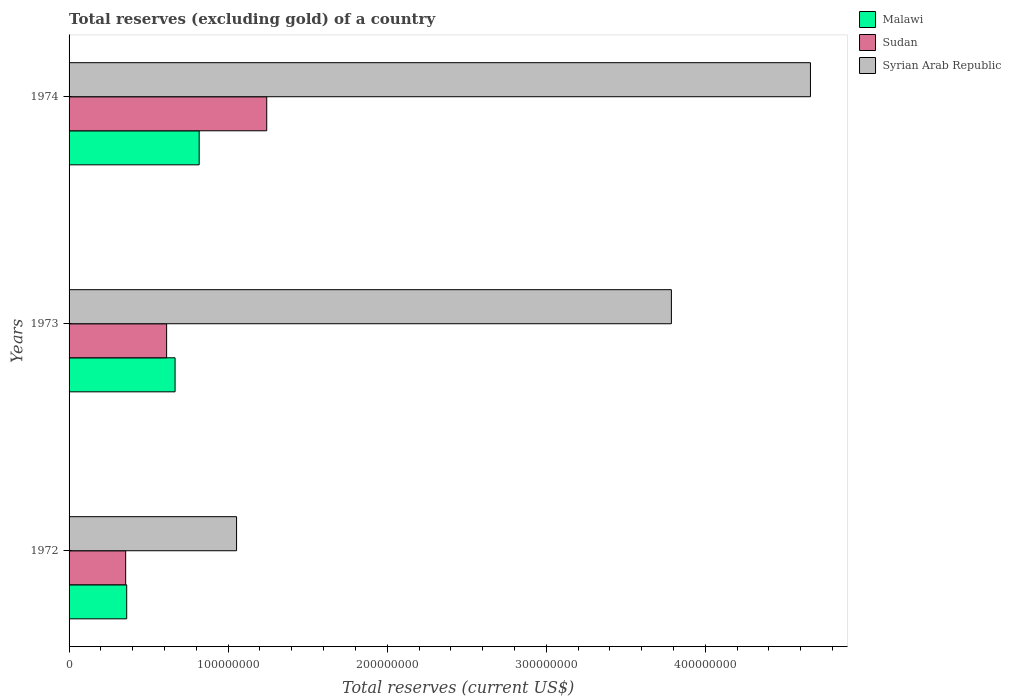How many groups of bars are there?
Your answer should be very brief. 3. Are the number of bars per tick equal to the number of legend labels?
Your response must be concise. Yes. Are the number of bars on each tick of the Y-axis equal?
Offer a terse response. Yes. How many bars are there on the 2nd tick from the top?
Your answer should be very brief. 3. What is the total reserves (excluding gold) in Malawi in 1972?
Your answer should be very brief. 3.62e+07. Across all years, what is the maximum total reserves (excluding gold) in Malawi?
Give a very brief answer. 8.18e+07. Across all years, what is the minimum total reserves (excluding gold) in Syrian Arab Republic?
Give a very brief answer. 1.05e+08. In which year was the total reserves (excluding gold) in Sudan maximum?
Make the answer very short. 1974. In which year was the total reserves (excluding gold) in Syrian Arab Republic minimum?
Give a very brief answer. 1972. What is the total total reserves (excluding gold) in Sudan in the graph?
Offer a terse response. 2.21e+08. What is the difference between the total reserves (excluding gold) in Malawi in 1972 and that in 1974?
Provide a short and direct response. -4.56e+07. What is the difference between the total reserves (excluding gold) in Syrian Arab Republic in 1973 and the total reserves (excluding gold) in Sudan in 1974?
Provide a short and direct response. 2.54e+08. What is the average total reserves (excluding gold) in Sudan per year?
Make the answer very short. 7.37e+07. In the year 1972, what is the difference between the total reserves (excluding gold) in Sudan and total reserves (excluding gold) in Malawi?
Provide a short and direct response. -6.50e+05. In how many years, is the total reserves (excluding gold) in Sudan greater than 160000000 US$?
Offer a terse response. 0. What is the ratio of the total reserves (excluding gold) in Syrian Arab Republic in 1972 to that in 1974?
Your response must be concise. 0.23. Is the total reserves (excluding gold) in Sudan in 1972 less than that in 1973?
Your response must be concise. Yes. Is the difference between the total reserves (excluding gold) in Sudan in 1972 and 1973 greater than the difference between the total reserves (excluding gold) in Malawi in 1972 and 1973?
Provide a short and direct response. Yes. What is the difference between the highest and the second highest total reserves (excluding gold) in Sudan?
Ensure brevity in your answer.  6.29e+07. What is the difference between the highest and the lowest total reserves (excluding gold) in Sudan?
Your response must be concise. 8.87e+07. Is the sum of the total reserves (excluding gold) in Syrian Arab Republic in 1972 and 1974 greater than the maximum total reserves (excluding gold) in Malawi across all years?
Offer a terse response. Yes. What does the 1st bar from the top in 1973 represents?
Offer a very short reply. Syrian Arab Republic. What does the 3rd bar from the bottom in 1972 represents?
Make the answer very short. Syrian Arab Republic. How many bars are there?
Keep it short and to the point. 9. Does the graph contain any zero values?
Offer a very short reply. No. Does the graph contain grids?
Give a very brief answer. No. Where does the legend appear in the graph?
Keep it short and to the point. Top right. What is the title of the graph?
Make the answer very short. Total reserves (excluding gold) of a country. Does "Bosnia and Herzegovina" appear as one of the legend labels in the graph?
Your response must be concise. No. What is the label or title of the X-axis?
Your response must be concise. Total reserves (current US$). What is the Total reserves (current US$) in Malawi in 1972?
Provide a short and direct response. 3.62e+07. What is the Total reserves (current US$) in Sudan in 1972?
Provide a succinct answer. 3.56e+07. What is the Total reserves (current US$) of Syrian Arab Republic in 1972?
Your response must be concise. 1.05e+08. What is the Total reserves (current US$) in Malawi in 1973?
Provide a short and direct response. 6.66e+07. What is the Total reserves (current US$) of Sudan in 1973?
Offer a very short reply. 6.13e+07. What is the Total reserves (current US$) of Syrian Arab Republic in 1973?
Your answer should be very brief. 3.79e+08. What is the Total reserves (current US$) of Malawi in 1974?
Provide a short and direct response. 8.18e+07. What is the Total reserves (current US$) in Sudan in 1974?
Keep it short and to the point. 1.24e+08. What is the Total reserves (current US$) of Syrian Arab Republic in 1974?
Make the answer very short. 4.66e+08. Across all years, what is the maximum Total reserves (current US$) of Malawi?
Ensure brevity in your answer.  8.18e+07. Across all years, what is the maximum Total reserves (current US$) in Sudan?
Provide a short and direct response. 1.24e+08. Across all years, what is the maximum Total reserves (current US$) of Syrian Arab Republic?
Provide a succinct answer. 4.66e+08. Across all years, what is the minimum Total reserves (current US$) of Malawi?
Give a very brief answer. 3.62e+07. Across all years, what is the minimum Total reserves (current US$) of Sudan?
Your response must be concise. 3.56e+07. Across all years, what is the minimum Total reserves (current US$) in Syrian Arab Republic?
Your answer should be very brief. 1.05e+08. What is the total Total reserves (current US$) of Malawi in the graph?
Your answer should be compact. 1.85e+08. What is the total Total reserves (current US$) of Sudan in the graph?
Your response must be concise. 2.21e+08. What is the total Total reserves (current US$) in Syrian Arab Republic in the graph?
Give a very brief answer. 9.50e+08. What is the difference between the Total reserves (current US$) in Malawi in 1972 and that in 1973?
Provide a succinct answer. -3.04e+07. What is the difference between the Total reserves (current US$) of Sudan in 1972 and that in 1973?
Your response must be concise. -2.57e+07. What is the difference between the Total reserves (current US$) in Syrian Arab Republic in 1972 and that in 1973?
Your answer should be compact. -2.73e+08. What is the difference between the Total reserves (current US$) in Malawi in 1972 and that in 1974?
Offer a very short reply. -4.56e+07. What is the difference between the Total reserves (current US$) in Sudan in 1972 and that in 1974?
Keep it short and to the point. -8.87e+07. What is the difference between the Total reserves (current US$) in Syrian Arab Republic in 1972 and that in 1974?
Your response must be concise. -3.61e+08. What is the difference between the Total reserves (current US$) of Malawi in 1973 and that in 1974?
Your answer should be very brief. -1.51e+07. What is the difference between the Total reserves (current US$) in Sudan in 1973 and that in 1974?
Ensure brevity in your answer.  -6.29e+07. What is the difference between the Total reserves (current US$) in Syrian Arab Republic in 1973 and that in 1974?
Your answer should be compact. -8.74e+07. What is the difference between the Total reserves (current US$) in Malawi in 1972 and the Total reserves (current US$) in Sudan in 1973?
Provide a succinct answer. -2.51e+07. What is the difference between the Total reserves (current US$) in Malawi in 1972 and the Total reserves (current US$) in Syrian Arab Republic in 1973?
Keep it short and to the point. -3.42e+08. What is the difference between the Total reserves (current US$) in Sudan in 1972 and the Total reserves (current US$) in Syrian Arab Republic in 1973?
Provide a succinct answer. -3.43e+08. What is the difference between the Total reserves (current US$) of Malawi in 1972 and the Total reserves (current US$) of Sudan in 1974?
Provide a succinct answer. -8.80e+07. What is the difference between the Total reserves (current US$) of Malawi in 1972 and the Total reserves (current US$) of Syrian Arab Republic in 1974?
Provide a succinct answer. -4.30e+08. What is the difference between the Total reserves (current US$) in Sudan in 1972 and the Total reserves (current US$) in Syrian Arab Republic in 1974?
Ensure brevity in your answer.  -4.31e+08. What is the difference between the Total reserves (current US$) of Malawi in 1973 and the Total reserves (current US$) of Sudan in 1974?
Keep it short and to the point. -5.76e+07. What is the difference between the Total reserves (current US$) of Malawi in 1973 and the Total reserves (current US$) of Syrian Arab Republic in 1974?
Give a very brief answer. -3.99e+08. What is the difference between the Total reserves (current US$) in Sudan in 1973 and the Total reserves (current US$) in Syrian Arab Republic in 1974?
Give a very brief answer. -4.05e+08. What is the average Total reserves (current US$) in Malawi per year?
Your answer should be very brief. 6.16e+07. What is the average Total reserves (current US$) in Sudan per year?
Your response must be concise. 7.37e+07. What is the average Total reserves (current US$) in Syrian Arab Republic per year?
Offer a terse response. 3.17e+08. In the year 1972, what is the difference between the Total reserves (current US$) of Malawi and Total reserves (current US$) of Sudan?
Ensure brevity in your answer.  6.50e+05. In the year 1972, what is the difference between the Total reserves (current US$) of Malawi and Total reserves (current US$) of Syrian Arab Republic?
Your answer should be compact. -6.91e+07. In the year 1972, what is the difference between the Total reserves (current US$) of Sudan and Total reserves (current US$) of Syrian Arab Republic?
Offer a very short reply. -6.97e+07. In the year 1973, what is the difference between the Total reserves (current US$) of Malawi and Total reserves (current US$) of Sudan?
Give a very brief answer. 5.31e+06. In the year 1973, what is the difference between the Total reserves (current US$) of Malawi and Total reserves (current US$) of Syrian Arab Republic?
Keep it short and to the point. -3.12e+08. In the year 1973, what is the difference between the Total reserves (current US$) of Sudan and Total reserves (current US$) of Syrian Arab Republic?
Offer a terse response. -3.17e+08. In the year 1974, what is the difference between the Total reserves (current US$) of Malawi and Total reserves (current US$) of Sudan?
Offer a very short reply. -4.25e+07. In the year 1974, what is the difference between the Total reserves (current US$) of Malawi and Total reserves (current US$) of Syrian Arab Republic?
Your response must be concise. -3.84e+08. In the year 1974, what is the difference between the Total reserves (current US$) of Sudan and Total reserves (current US$) of Syrian Arab Republic?
Offer a very short reply. -3.42e+08. What is the ratio of the Total reserves (current US$) in Malawi in 1972 to that in 1973?
Offer a very short reply. 0.54. What is the ratio of the Total reserves (current US$) of Sudan in 1972 to that in 1973?
Provide a succinct answer. 0.58. What is the ratio of the Total reserves (current US$) in Syrian Arab Republic in 1972 to that in 1973?
Your answer should be very brief. 0.28. What is the ratio of the Total reserves (current US$) of Malawi in 1972 to that in 1974?
Your answer should be very brief. 0.44. What is the ratio of the Total reserves (current US$) in Sudan in 1972 to that in 1974?
Offer a terse response. 0.29. What is the ratio of the Total reserves (current US$) of Syrian Arab Republic in 1972 to that in 1974?
Make the answer very short. 0.23. What is the ratio of the Total reserves (current US$) of Malawi in 1973 to that in 1974?
Make the answer very short. 0.81. What is the ratio of the Total reserves (current US$) of Sudan in 1973 to that in 1974?
Offer a very short reply. 0.49. What is the ratio of the Total reserves (current US$) of Syrian Arab Republic in 1973 to that in 1974?
Ensure brevity in your answer.  0.81. What is the difference between the highest and the second highest Total reserves (current US$) of Malawi?
Give a very brief answer. 1.51e+07. What is the difference between the highest and the second highest Total reserves (current US$) of Sudan?
Offer a terse response. 6.29e+07. What is the difference between the highest and the second highest Total reserves (current US$) in Syrian Arab Republic?
Your answer should be very brief. 8.74e+07. What is the difference between the highest and the lowest Total reserves (current US$) of Malawi?
Your answer should be compact. 4.56e+07. What is the difference between the highest and the lowest Total reserves (current US$) of Sudan?
Offer a very short reply. 8.87e+07. What is the difference between the highest and the lowest Total reserves (current US$) of Syrian Arab Republic?
Offer a terse response. 3.61e+08. 